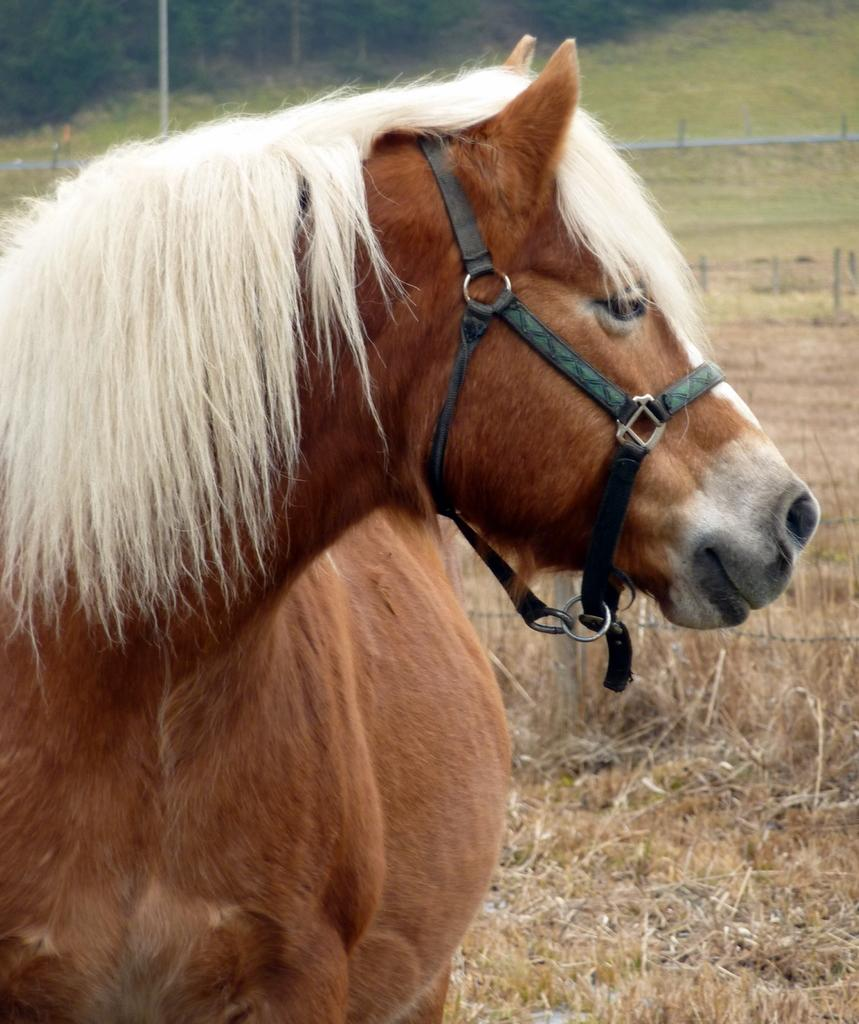What animal is present in the image? There is a horse in the image. Where is the horse standing? The horse is standing on the grass. What can be seen in the background of the image? There is mesh, poles, the ground, and trees visible in the background of the image. What type of instrument is being played by the horse in the image? There is no instrument being played by the horse in the image, as it is a still image of a horse standing on grass. 